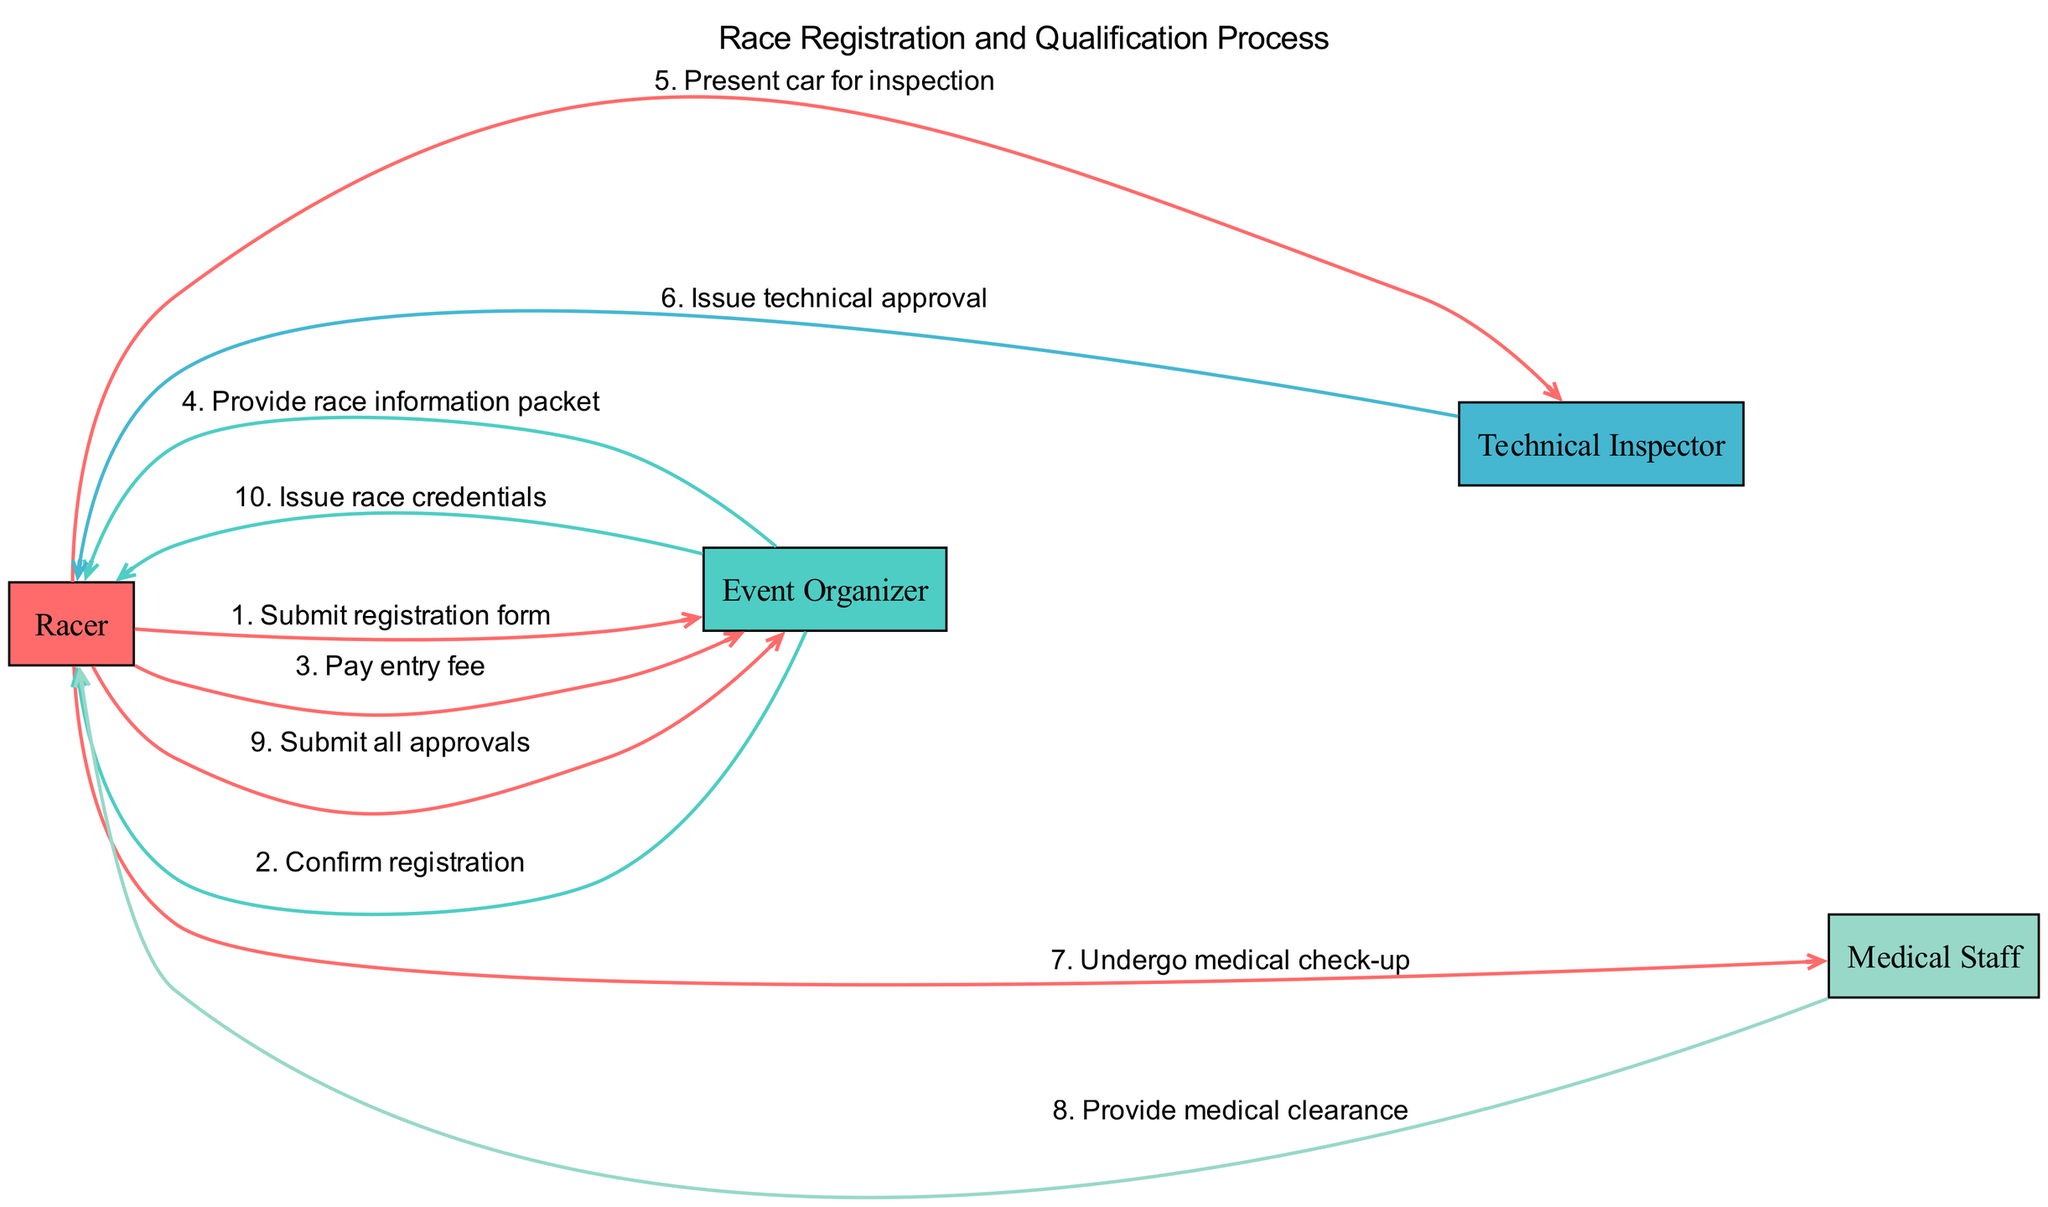What's the first action that a Racer takes? The first action in the sequence is the Racer submitting the registration form to the Event Organizer. This is shown at the beginning of the diagram, where the Racer initiates the process.
Answer: Submit registration form How many actors are involved in the registration process? The diagram identifies four distinct actors: Racer, Event Organizer, Technical Inspector, and Medical Staff. By counting the unique labels in the diagram, we find there are four actors.
Answer: Four What does the Event Organizer provide after confirming registration? After confirming the registration, the Event Organizer provides the Racer with a race information packet. This is indicated as a direct action following the confirmation of the registration.
Answer: Provide race information packet What does the Racer need to undergo before obtaining race credentials? Before the Racer can obtain race credentials, they must undergo a medical check-up. This is a condition that must be completed according to the sequence displayed, leading up to the submission of all approvals.
Answer: Undergo medical check-up Which actor issues technical approval? The Technical Inspector is the actor responsible for issuing technical approval after the Racer presents the car for inspection. This label and action are clear in the flow of the diagram.
Answer: Technical Inspector What is the last action taken in the sequence? The last action in the sequence diagram is the Event Organizer issuing race credentials to the Racer once all necessary approvals have been submitted. This action concludes the registration and qualification process.
Answer: Issue race credentials Describe the action that follows the Racer submitting all approvals. After the Racer submits all required approvals, the next action is taken by the Event Organizer, who then issues the race credentials. This portion of the sequence indicates the completion of the registration process.
Answer: Issue race credentials How many actions does the Racer participate in? The Racer is involved in a total of five actions throughout the process, including submitting the registration form, paying the entry fee, presenting the car for inspection, undergoing a medical check-up, and submitting all approvals. By counting these specific actions tied to the Racer, we confirm the total.
Answer: Five 